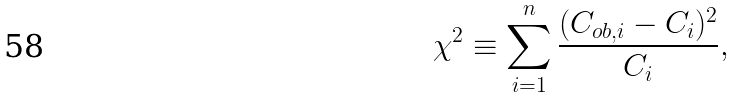Convert formula to latex. <formula><loc_0><loc_0><loc_500><loc_500>\chi ^ { 2 } \equiv \sum _ { i = 1 } ^ { n } \frac { ( C _ { o b , i } - C _ { i } ) ^ { 2 } } { C _ { i } } ,</formula> 